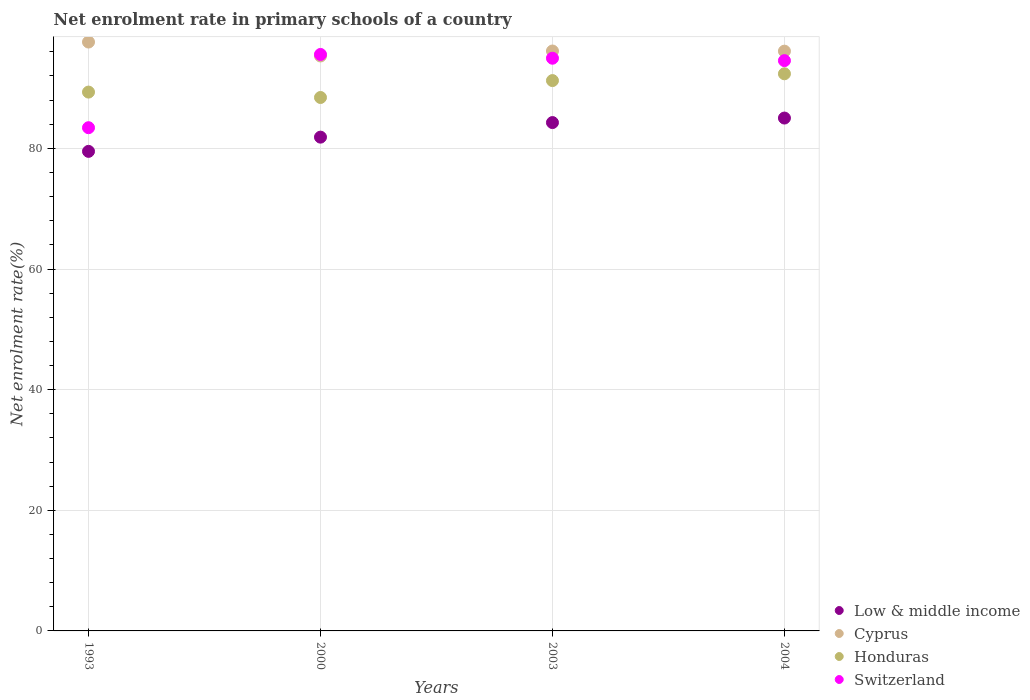Is the number of dotlines equal to the number of legend labels?
Offer a terse response. Yes. What is the net enrolment rate in primary schools in Switzerland in 2004?
Offer a very short reply. 94.55. Across all years, what is the maximum net enrolment rate in primary schools in Cyprus?
Ensure brevity in your answer.  97.63. Across all years, what is the minimum net enrolment rate in primary schools in Low & middle income?
Provide a succinct answer. 79.5. In which year was the net enrolment rate in primary schools in Switzerland minimum?
Provide a short and direct response. 1993. What is the total net enrolment rate in primary schools in Honduras in the graph?
Keep it short and to the point. 361.38. What is the difference between the net enrolment rate in primary schools in Honduras in 2003 and that in 2004?
Your answer should be compact. -1.13. What is the difference between the net enrolment rate in primary schools in Honduras in 1993 and the net enrolment rate in primary schools in Cyprus in 2003?
Offer a very short reply. -6.81. What is the average net enrolment rate in primary schools in Cyprus per year?
Keep it short and to the point. 96.3. In the year 2003, what is the difference between the net enrolment rate in primary schools in Switzerland and net enrolment rate in primary schools in Low & middle income?
Your answer should be compact. 10.67. What is the ratio of the net enrolment rate in primary schools in Low & middle income in 2000 to that in 2003?
Give a very brief answer. 0.97. Is the difference between the net enrolment rate in primary schools in Switzerland in 1993 and 2000 greater than the difference between the net enrolment rate in primary schools in Low & middle income in 1993 and 2000?
Keep it short and to the point. No. What is the difference between the highest and the second highest net enrolment rate in primary schools in Switzerland?
Offer a very short reply. 0.63. What is the difference between the highest and the lowest net enrolment rate in primary schools in Switzerland?
Offer a very short reply. 12.15. Is it the case that in every year, the sum of the net enrolment rate in primary schools in Low & middle income and net enrolment rate in primary schools in Switzerland  is greater than the net enrolment rate in primary schools in Cyprus?
Provide a short and direct response. Yes. Is the net enrolment rate in primary schools in Low & middle income strictly greater than the net enrolment rate in primary schools in Honduras over the years?
Your answer should be very brief. No. Is the net enrolment rate in primary schools in Cyprus strictly less than the net enrolment rate in primary schools in Honduras over the years?
Your response must be concise. No. How many dotlines are there?
Offer a very short reply. 4. How many years are there in the graph?
Give a very brief answer. 4. Are the values on the major ticks of Y-axis written in scientific E-notation?
Provide a succinct answer. No. How many legend labels are there?
Keep it short and to the point. 4. How are the legend labels stacked?
Offer a very short reply. Vertical. What is the title of the graph?
Offer a terse response. Net enrolment rate in primary schools of a country. Does "Low income" appear as one of the legend labels in the graph?
Offer a terse response. No. What is the label or title of the X-axis?
Ensure brevity in your answer.  Years. What is the label or title of the Y-axis?
Offer a very short reply. Net enrolment rate(%). What is the Net enrolment rate(%) of Low & middle income in 1993?
Offer a very short reply. 79.5. What is the Net enrolment rate(%) of Cyprus in 1993?
Your answer should be very brief. 97.63. What is the Net enrolment rate(%) in Honduras in 1993?
Provide a short and direct response. 89.33. What is the Net enrolment rate(%) in Switzerland in 1993?
Provide a succinct answer. 83.43. What is the Net enrolment rate(%) in Low & middle income in 2000?
Your answer should be compact. 81.86. What is the Net enrolment rate(%) in Cyprus in 2000?
Your answer should be very brief. 95.32. What is the Net enrolment rate(%) in Honduras in 2000?
Your answer should be very brief. 88.44. What is the Net enrolment rate(%) of Switzerland in 2000?
Keep it short and to the point. 95.57. What is the Net enrolment rate(%) of Low & middle income in 2003?
Your answer should be compact. 84.28. What is the Net enrolment rate(%) of Cyprus in 2003?
Offer a terse response. 96.14. What is the Net enrolment rate(%) in Honduras in 2003?
Provide a succinct answer. 91.24. What is the Net enrolment rate(%) in Switzerland in 2003?
Offer a very short reply. 94.95. What is the Net enrolment rate(%) of Low & middle income in 2004?
Make the answer very short. 85.03. What is the Net enrolment rate(%) of Cyprus in 2004?
Your answer should be very brief. 96.12. What is the Net enrolment rate(%) in Honduras in 2004?
Make the answer very short. 92.37. What is the Net enrolment rate(%) in Switzerland in 2004?
Make the answer very short. 94.55. Across all years, what is the maximum Net enrolment rate(%) in Low & middle income?
Give a very brief answer. 85.03. Across all years, what is the maximum Net enrolment rate(%) in Cyprus?
Make the answer very short. 97.63. Across all years, what is the maximum Net enrolment rate(%) in Honduras?
Keep it short and to the point. 92.37. Across all years, what is the maximum Net enrolment rate(%) in Switzerland?
Provide a short and direct response. 95.57. Across all years, what is the minimum Net enrolment rate(%) in Low & middle income?
Your answer should be compact. 79.5. Across all years, what is the minimum Net enrolment rate(%) of Cyprus?
Offer a very short reply. 95.32. Across all years, what is the minimum Net enrolment rate(%) of Honduras?
Provide a succinct answer. 88.44. Across all years, what is the minimum Net enrolment rate(%) of Switzerland?
Keep it short and to the point. 83.43. What is the total Net enrolment rate(%) in Low & middle income in the graph?
Your answer should be compact. 330.67. What is the total Net enrolment rate(%) of Cyprus in the graph?
Provide a short and direct response. 385.21. What is the total Net enrolment rate(%) of Honduras in the graph?
Ensure brevity in your answer.  361.38. What is the total Net enrolment rate(%) of Switzerland in the graph?
Offer a very short reply. 368.5. What is the difference between the Net enrolment rate(%) in Low & middle income in 1993 and that in 2000?
Your answer should be compact. -2.36. What is the difference between the Net enrolment rate(%) of Cyprus in 1993 and that in 2000?
Make the answer very short. 2.31. What is the difference between the Net enrolment rate(%) of Honduras in 1993 and that in 2000?
Make the answer very short. 0.9. What is the difference between the Net enrolment rate(%) in Switzerland in 1993 and that in 2000?
Offer a very short reply. -12.15. What is the difference between the Net enrolment rate(%) in Low & middle income in 1993 and that in 2003?
Your answer should be very brief. -4.77. What is the difference between the Net enrolment rate(%) in Cyprus in 1993 and that in 2003?
Ensure brevity in your answer.  1.49. What is the difference between the Net enrolment rate(%) in Honduras in 1993 and that in 2003?
Make the answer very short. -1.91. What is the difference between the Net enrolment rate(%) in Switzerland in 1993 and that in 2003?
Your response must be concise. -11.52. What is the difference between the Net enrolment rate(%) in Low & middle income in 1993 and that in 2004?
Keep it short and to the point. -5.52. What is the difference between the Net enrolment rate(%) of Cyprus in 1993 and that in 2004?
Your response must be concise. 1.51. What is the difference between the Net enrolment rate(%) of Honduras in 1993 and that in 2004?
Your answer should be very brief. -3.03. What is the difference between the Net enrolment rate(%) of Switzerland in 1993 and that in 2004?
Your answer should be compact. -11.12. What is the difference between the Net enrolment rate(%) in Low & middle income in 2000 and that in 2003?
Ensure brevity in your answer.  -2.42. What is the difference between the Net enrolment rate(%) of Cyprus in 2000 and that in 2003?
Offer a very short reply. -0.82. What is the difference between the Net enrolment rate(%) in Honduras in 2000 and that in 2003?
Your answer should be compact. -2.8. What is the difference between the Net enrolment rate(%) in Switzerland in 2000 and that in 2003?
Your response must be concise. 0.63. What is the difference between the Net enrolment rate(%) in Low & middle income in 2000 and that in 2004?
Your answer should be very brief. -3.17. What is the difference between the Net enrolment rate(%) of Cyprus in 2000 and that in 2004?
Make the answer very short. -0.8. What is the difference between the Net enrolment rate(%) in Honduras in 2000 and that in 2004?
Make the answer very short. -3.93. What is the difference between the Net enrolment rate(%) in Switzerland in 2000 and that in 2004?
Your answer should be very brief. 1.03. What is the difference between the Net enrolment rate(%) of Low & middle income in 2003 and that in 2004?
Offer a very short reply. -0.75. What is the difference between the Net enrolment rate(%) in Cyprus in 2003 and that in 2004?
Your answer should be compact. 0.03. What is the difference between the Net enrolment rate(%) in Honduras in 2003 and that in 2004?
Your answer should be very brief. -1.13. What is the difference between the Net enrolment rate(%) of Switzerland in 2003 and that in 2004?
Provide a short and direct response. 0.4. What is the difference between the Net enrolment rate(%) of Low & middle income in 1993 and the Net enrolment rate(%) of Cyprus in 2000?
Ensure brevity in your answer.  -15.81. What is the difference between the Net enrolment rate(%) in Low & middle income in 1993 and the Net enrolment rate(%) in Honduras in 2000?
Give a very brief answer. -8.93. What is the difference between the Net enrolment rate(%) of Low & middle income in 1993 and the Net enrolment rate(%) of Switzerland in 2000?
Your answer should be compact. -16.07. What is the difference between the Net enrolment rate(%) in Cyprus in 1993 and the Net enrolment rate(%) in Honduras in 2000?
Offer a very short reply. 9.19. What is the difference between the Net enrolment rate(%) of Cyprus in 1993 and the Net enrolment rate(%) of Switzerland in 2000?
Offer a very short reply. 2.06. What is the difference between the Net enrolment rate(%) of Honduras in 1993 and the Net enrolment rate(%) of Switzerland in 2000?
Offer a very short reply. -6.24. What is the difference between the Net enrolment rate(%) in Low & middle income in 1993 and the Net enrolment rate(%) in Cyprus in 2003?
Make the answer very short. -16.64. What is the difference between the Net enrolment rate(%) in Low & middle income in 1993 and the Net enrolment rate(%) in Honduras in 2003?
Ensure brevity in your answer.  -11.74. What is the difference between the Net enrolment rate(%) in Low & middle income in 1993 and the Net enrolment rate(%) in Switzerland in 2003?
Your answer should be compact. -15.44. What is the difference between the Net enrolment rate(%) in Cyprus in 1993 and the Net enrolment rate(%) in Honduras in 2003?
Make the answer very short. 6.39. What is the difference between the Net enrolment rate(%) in Cyprus in 1993 and the Net enrolment rate(%) in Switzerland in 2003?
Offer a very short reply. 2.68. What is the difference between the Net enrolment rate(%) of Honduras in 1993 and the Net enrolment rate(%) of Switzerland in 2003?
Make the answer very short. -5.61. What is the difference between the Net enrolment rate(%) in Low & middle income in 1993 and the Net enrolment rate(%) in Cyprus in 2004?
Your answer should be compact. -16.61. What is the difference between the Net enrolment rate(%) in Low & middle income in 1993 and the Net enrolment rate(%) in Honduras in 2004?
Your response must be concise. -12.86. What is the difference between the Net enrolment rate(%) of Low & middle income in 1993 and the Net enrolment rate(%) of Switzerland in 2004?
Offer a terse response. -15.04. What is the difference between the Net enrolment rate(%) in Cyprus in 1993 and the Net enrolment rate(%) in Honduras in 2004?
Your response must be concise. 5.26. What is the difference between the Net enrolment rate(%) in Cyprus in 1993 and the Net enrolment rate(%) in Switzerland in 2004?
Give a very brief answer. 3.08. What is the difference between the Net enrolment rate(%) of Honduras in 1993 and the Net enrolment rate(%) of Switzerland in 2004?
Your answer should be compact. -5.22. What is the difference between the Net enrolment rate(%) in Low & middle income in 2000 and the Net enrolment rate(%) in Cyprus in 2003?
Provide a succinct answer. -14.28. What is the difference between the Net enrolment rate(%) of Low & middle income in 2000 and the Net enrolment rate(%) of Honduras in 2003?
Provide a succinct answer. -9.38. What is the difference between the Net enrolment rate(%) of Low & middle income in 2000 and the Net enrolment rate(%) of Switzerland in 2003?
Your answer should be very brief. -13.08. What is the difference between the Net enrolment rate(%) of Cyprus in 2000 and the Net enrolment rate(%) of Honduras in 2003?
Give a very brief answer. 4.08. What is the difference between the Net enrolment rate(%) in Cyprus in 2000 and the Net enrolment rate(%) in Switzerland in 2003?
Ensure brevity in your answer.  0.37. What is the difference between the Net enrolment rate(%) in Honduras in 2000 and the Net enrolment rate(%) in Switzerland in 2003?
Provide a short and direct response. -6.51. What is the difference between the Net enrolment rate(%) in Low & middle income in 2000 and the Net enrolment rate(%) in Cyprus in 2004?
Make the answer very short. -14.26. What is the difference between the Net enrolment rate(%) in Low & middle income in 2000 and the Net enrolment rate(%) in Honduras in 2004?
Offer a very short reply. -10.5. What is the difference between the Net enrolment rate(%) in Low & middle income in 2000 and the Net enrolment rate(%) in Switzerland in 2004?
Provide a succinct answer. -12.69. What is the difference between the Net enrolment rate(%) in Cyprus in 2000 and the Net enrolment rate(%) in Honduras in 2004?
Offer a very short reply. 2.95. What is the difference between the Net enrolment rate(%) of Cyprus in 2000 and the Net enrolment rate(%) of Switzerland in 2004?
Your answer should be very brief. 0.77. What is the difference between the Net enrolment rate(%) in Honduras in 2000 and the Net enrolment rate(%) in Switzerland in 2004?
Offer a very short reply. -6.11. What is the difference between the Net enrolment rate(%) in Low & middle income in 2003 and the Net enrolment rate(%) in Cyprus in 2004?
Provide a short and direct response. -11.84. What is the difference between the Net enrolment rate(%) in Low & middle income in 2003 and the Net enrolment rate(%) in Honduras in 2004?
Offer a very short reply. -8.09. What is the difference between the Net enrolment rate(%) in Low & middle income in 2003 and the Net enrolment rate(%) in Switzerland in 2004?
Your answer should be very brief. -10.27. What is the difference between the Net enrolment rate(%) in Cyprus in 2003 and the Net enrolment rate(%) in Honduras in 2004?
Your answer should be very brief. 3.78. What is the difference between the Net enrolment rate(%) of Cyprus in 2003 and the Net enrolment rate(%) of Switzerland in 2004?
Your answer should be compact. 1.6. What is the difference between the Net enrolment rate(%) in Honduras in 2003 and the Net enrolment rate(%) in Switzerland in 2004?
Offer a terse response. -3.31. What is the average Net enrolment rate(%) of Low & middle income per year?
Offer a terse response. 82.67. What is the average Net enrolment rate(%) in Cyprus per year?
Provide a short and direct response. 96.3. What is the average Net enrolment rate(%) in Honduras per year?
Offer a terse response. 90.34. What is the average Net enrolment rate(%) of Switzerland per year?
Keep it short and to the point. 92.12. In the year 1993, what is the difference between the Net enrolment rate(%) in Low & middle income and Net enrolment rate(%) in Cyprus?
Make the answer very short. -18.12. In the year 1993, what is the difference between the Net enrolment rate(%) in Low & middle income and Net enrolment rate(%) in Honduras?
Offer a terse response. -9.83. In the year 1993, what is the difference between the Net enrolment rate(%) in Low & middle income and Net enrolment rate(%) in Switzerland?
Offer a terse response. -3.92. In the year 1993, what is the difference between the Net enrolment rate(%) of Cyprus and Net enrolment rate(%) of Honduras?
Your response must be concise. 8.3. In the year 1993, what is the difference between the Net enrolment rate(%) in Cyprus and Net enrolment rate(%) in Switzerland?
Keep it short and to the point. 14.2. In the year 1993, what is the difference between the Net enrolment rate(%) in Honduras and Net enrolment rate(%) in Switzerland?
Give a very brief answer. 5.91. In the year 2000, what is the difference between the Net enrolment rate(%) in Low & middle income and Net enrolment rate(%) in Cyprus?
Provide a succinct answer. -13.46. In the year 2000, what is the difference between the Net enrolment rate(%) in Low & middle income and Net enrolment rate(%) in Honduras?
Provide a short and direct response. -6.57. In the year 2000, what is the difference between the Net enrolment rate(%) in Low & middle income and Net enrolment rate(%) in Switzerland?
Ensure brevity in your answer.  -13.71. In the year 2000, what is the difference between the Net enrolment rate(%) of Cyprus and Net enrolment rate(%) of Honduras?
Provide a succinct answer. 6.88. In the year 2000, what is the difference between the Net enrolment rate(%) of Cyprus and Net enrolment rate(%) of Switzerland?
Your answer should be very brief. -0.26. In the year 2000, what is the difference between the Net enrolment rate(%) of Honduras and Net enrolment rate(%) of Switzerland?
Give a very brief answer. -7.14. In the year 2003, what is the difference between the Net enrolment rate(%) in Low & middle income and Net enrolment rate(%) in Cyprus?
Ensure brevity in your answer.  -11.87. In the year 2003, what is the difference between the Net enrolment rate(%) in Low & middle income and Net enrolment rate(%) in Honduras?
Your answer should be compact. -6.96. In the year 2003, what is the difference between the Net enrolment rate(%) in Low & middle income and Net enrolment rate(%) in Switzerland?
Ensure brevity in your answer.  -10.67. In the year 2003, what is the difference between the Net enrolment rate(%) in Cyprus and Net enrolment rate(%) in Honduras?
Your response must be concise. 4.9. In the year 2003, what is the difference between the Net enrolment rate(%) in Cyprus and Net enrolment rate(%) in Switzerland?
Your response must be concise. 1.2. In the year 2003, what is the difference between the Net enrolment rate(%) of Honduras and Net enrolment rate(%) of Switzerland?
Ensure brevity in your answer.  -3.71. In the year 2004, what is the difference between the Net enrolment rate(%) of Low & middle income and Net enrolment rate(%) of Cyprus?
Keep it short and to the point. -11.09. In the year 2004, what is the difference between the Net enrolment rate(%) in Low & middle income and Net enrolment rate(%) in Honduras?
Keep it short and to the point. -7.34. In the year 2004, what is the difference between the Net enrolment rate(%) in Low & middle income and Net enrolment rate(%) in Switzerland?
Offer a terse response. -9.52. In the year 2004, what is the difference between the Net enrolment rate(%) in Cyprus and Net enrolment rate(%) in Honduras?
Ensure brevity in your answer.  3.75. In the year 2004, what is the difference between the Net enrolment rate(%) in Cyprus and Net enrolment rate(%) in Switzerland?
Ensure brevity in your answer.  1.57. In the year 2004, what is the difference between the Net enrolment rate(%) of Honduras and Net enrolment rate(%) of Switzerland?
Offer a terse response. -2.18. What is the ratio of the Net enrolment rate(%) of Low & middle income in 1993 to that in 2000?
Make the answer very short. 0.97. What is the ratio of the Net enrolment rate(%) in Cyprus in 1993 to that in 2000?
Your answer should be compact. 1.02. What is the ratio of the Net enrolment rate(%) in Honduras in 1993 to that in 2000?
Give a very brief answer. 1.01. What is the ratio of the Net enrolment rate(%) in Switzerland in 1993 to that in 2000?
Offer a very short reply. 0.87. What is the ratio of the Net enrolment rate(%) in Low & middle income in 1993 to that in 2003?
Provide a short and direct response. 0.94. What is the ratio of the Net enrolment rate(%) of Cyprus in 1993 to that in 2003?
Give a very brief answer. 1.02. What is the ratio of the Net enrolment rate(%) in Honduras in 1993 to that in 2003?
Offer a very short reply. 0.98. What is the ratio of the Net enrolment rate(%) of Switzerland in 1993 to that in 2003?
Provide a succinct answer. 0.88. What is the ratio of the Net enrolment rate(%) in Low & middle income in 1993 to that in 2004?
Provide a short and direct response. 0.94. What is the ratio of the Net enrolment rate(%) in Cyprus in 1993 to that in 2004?
Provide a succinct answer. 1.02. What is the ratio of the Net enrolment rate(%) of Honduras in 1993 to that in 2004?
Offer a very short reply. 0.97. What is the ratio of the Net enrolment rate(%) in Switzerland in 1993 to that in 2004?
Your response must be concise. 0.88. What is the ratio of the Net enrolment rate(%) in Low & middle income in 2000 to that in 2003?
Ensure brevity in your answer.  0.97. What is the ratio of the Net enrolment rate(%) of Cyprus in 2000 to that in 2003?
Offer a very short reply. 0.99. What is the ratio of the Net enrolment rate(%) of Honduras in 2000 to that in 2003?
Your response must be concise. 0.97. What is the ratio of the Net enrolment rate(%) of Switzerland in 2000 to that in 2003?
Your answer should be very brief. 1.01. What is the ratio of the Net enrolment rate(%) of Low & middle income in 2000 to that in 2004?
Provide a succinct answer. 0.96. What is the ratio of the Net enrolment rate(%) of Honduras in 2000 to that in 2004?
Offer a terse response. 0.96. What is the ratio of the Net enrolment rate(%) of Switzerland in 2000 to that in 2004?
Provide a succinct answer. 1.01. What is the ratio of the Net enrolment rate(%) in Low & middle income in 2003 to that in 2004?
Make the answer very short. 0.99. What is the ratio of the Net enrolment rate(%) of Cyprus in 2003 to that in 2004?
Your answer should be very brief. 1. What is the ratio of the Net enrolment rate(%) of Honduras in 2003 to that in 2004?
Your answer should be very brief. 0.99. What is the ratio of the Net enrolment rate(%) in Switzerland in 2003 to that in 2004?
Keep it short and to the point. 1. What is the difference between the highest and the second highest Net enrolment rate(%) of Low & middle income?
Your answer should be very brief. 0.75. What is the difference between the highest and the second highest Net enrolment rate(%) of Cyprus?
Offer a very short reply. 1.49. What is the difference between the highest and the second highest Net enrolment rate(%) in Honduras?
Make the answer very short. 1.13. What is the difference between the highest and the second highest Net enrolment rate(%) in Switzerland?
Ensure brevity in your answer.  0.63. What is the difference between the highest and the lowest Net enrolment rate(%) in Low & middle income?
Provide a short and direct response. 5.52. What is the difference between the highest and the lowest Net enrolment rate(%) of Cyprus?
Ensure brevity in your answer.  2.31. What is the difference between the highest and the lowest Net enrolment rate(%) of Honduras?
Your answer should be compact. 3.93. What is the difference between the highest and the lowest Net enrolment rate(%) in Switzerland?
Give a very brief answer. 12.15. 